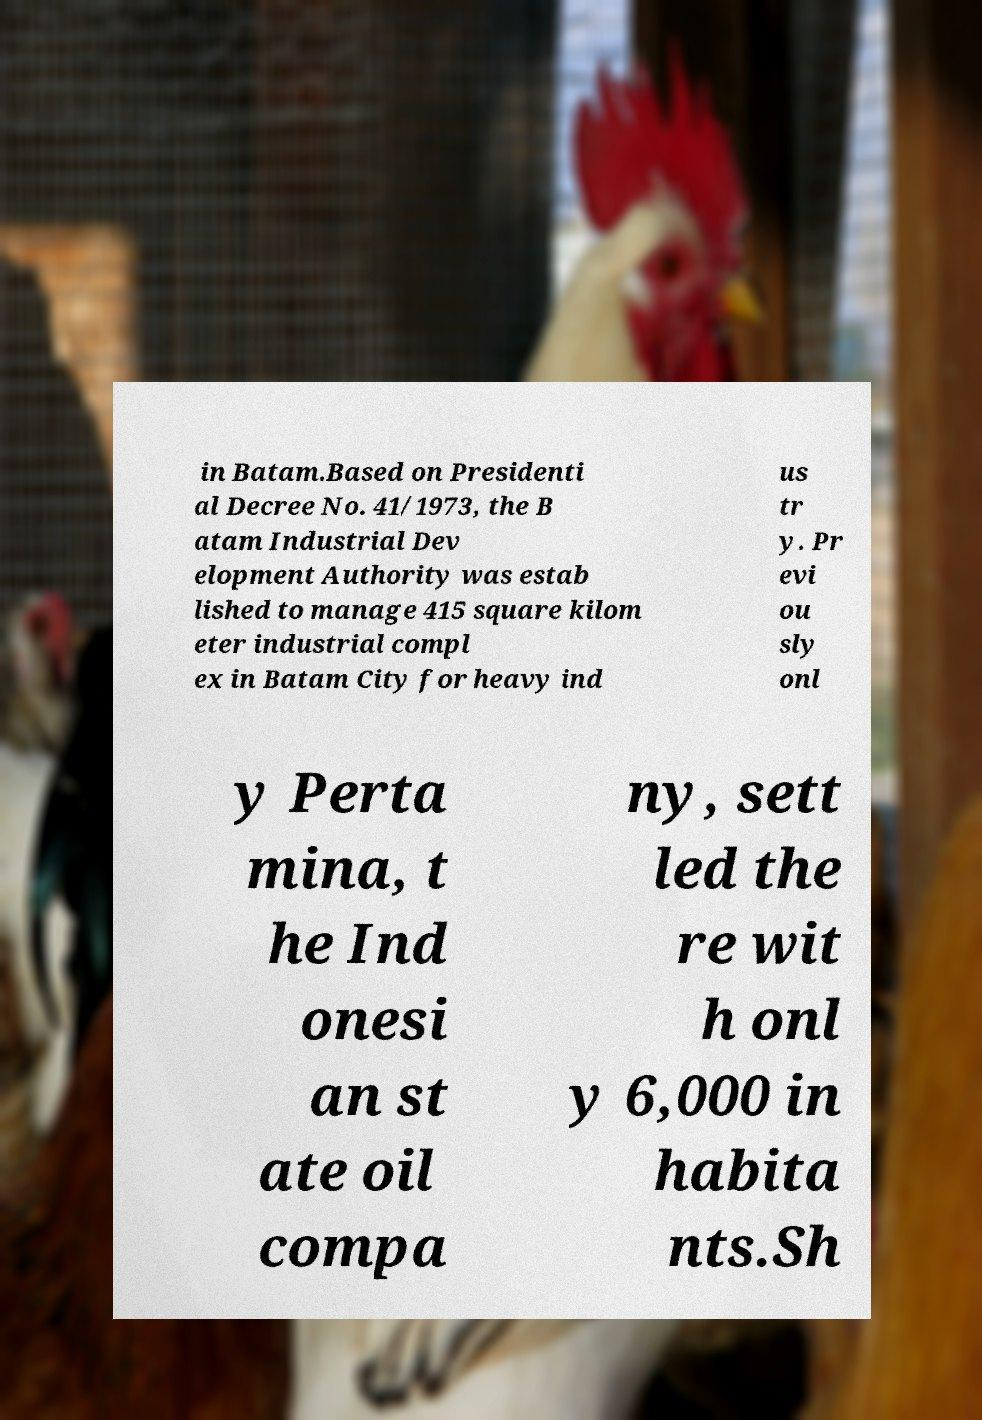What messages or text are displayed in this image? I need them in a readable, typed format. in Batam.Based on Presidenti al Decree No. 41/1973, the B atam Industrial Dev elopment Authority was estab lished to manage 415 square kilom eter industrial compl ex in Batam City for heavy ind us tr y. Pr evi ou sly onl y Perta mina, t he Ind onesi an st ate oil compa ny, sett led the re wit h onl y 6,000 in habita nts.Sh 